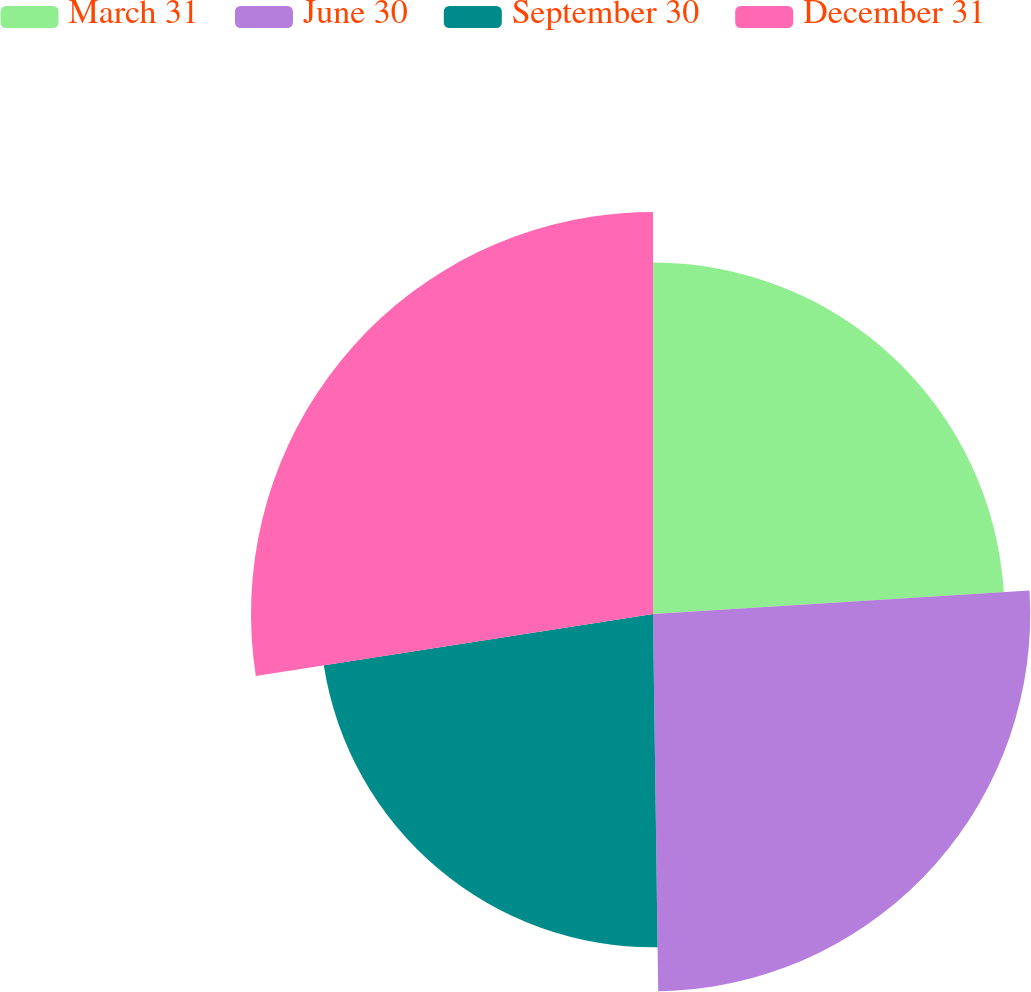<chart> <loc_0><loc_0><loc_500><loc_500><pie_chart><fcel>March 31<fcel>June 30<fcel>September 30<fcel>December 31<nl><fcel>24.01%<fcel>25.77%<fcel>22.76%<fcel>27.46%<nl></chart> 